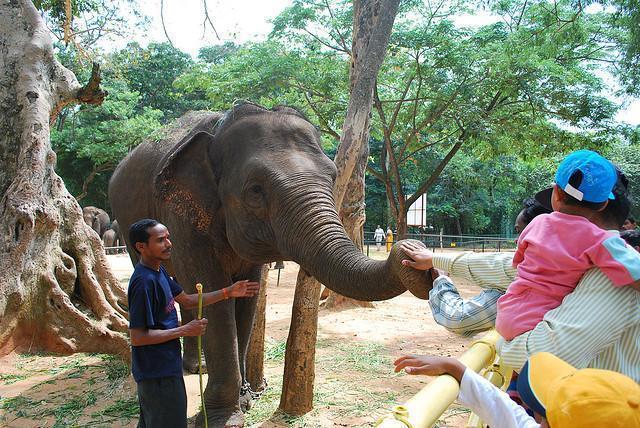What Disney cartoon character is based on this animal?
Pick the right solution, then justify: 'Answer: answer
Rationale: rationale.'
Options: Barbie, dumbo, genie, aladdin. Answer: dumbo.
Rationale: The animal is an elephant. 